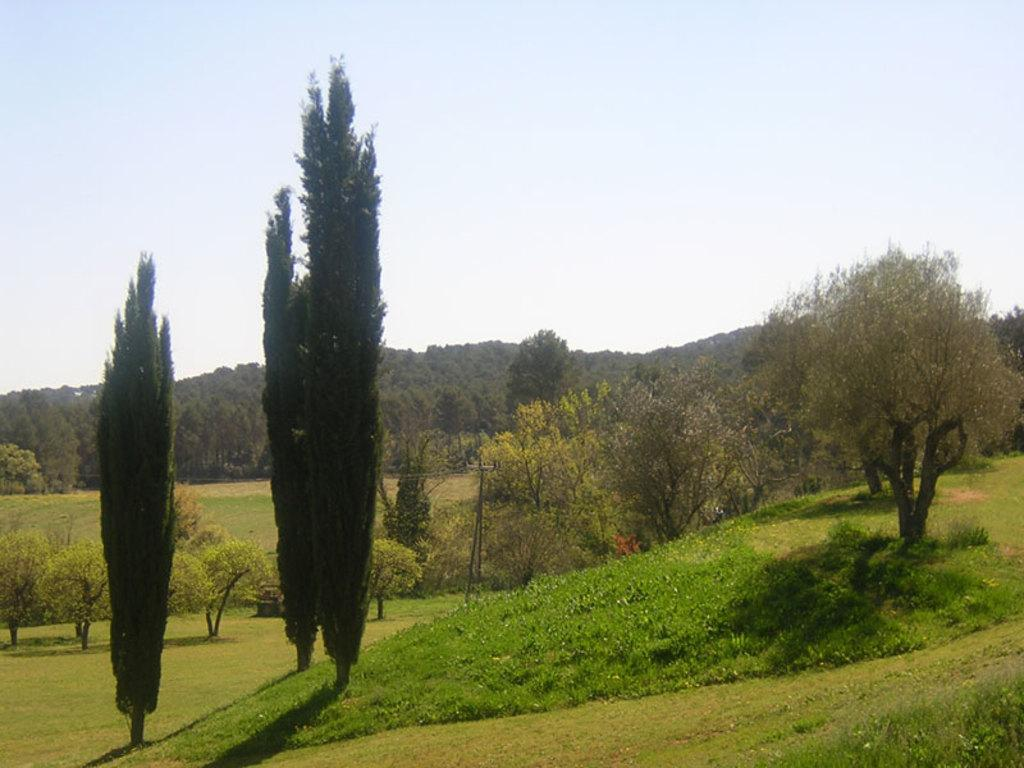What type of vegetation is visible in the image? There are trees in the image. What is covering the ground in the image? There is grass on the ground in the image. What is the condition of the sky in the image? The sky is cloudy in the image. Can you see the mother holding the cannon in the image? There is no mother or cannon present in the image. What type of fuel is being used by the trees in the image? Trees do not use fuel; they produce their own energy through photosynthesis. 